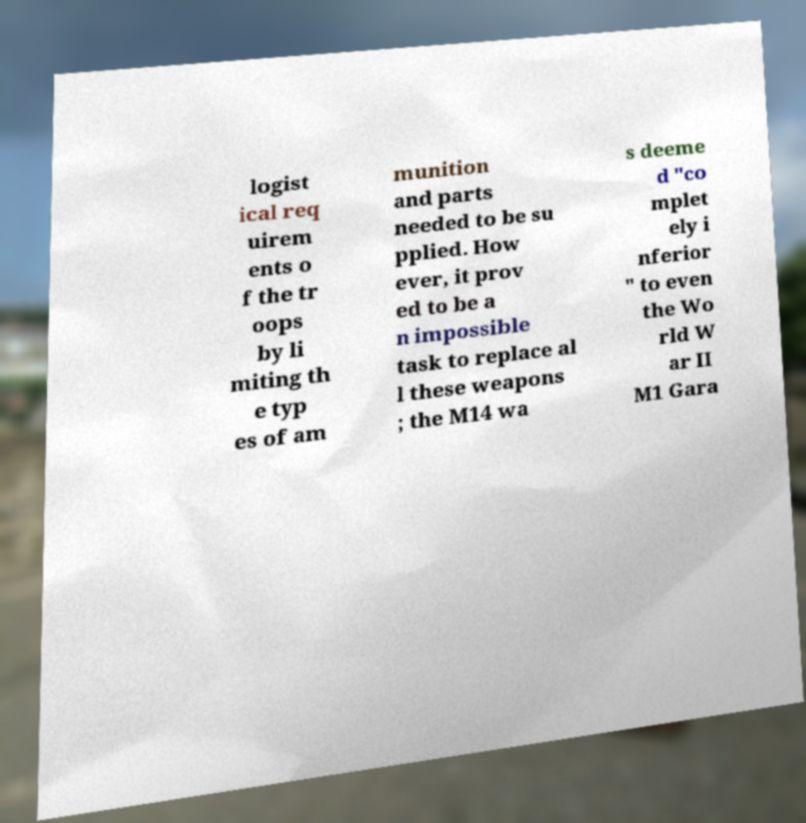Could you extract and type out the text from this image? logist ical req uirem ents o f the tr oops by li miting th e typ es of am munition and parts needed to be su pplied. How ever, it prov ed to be a n impossible task to replace al l these weapons ; the M14 wa s deeme d "co mplet ely i nferior " to even the Wo rld W ar II M1 Gara 